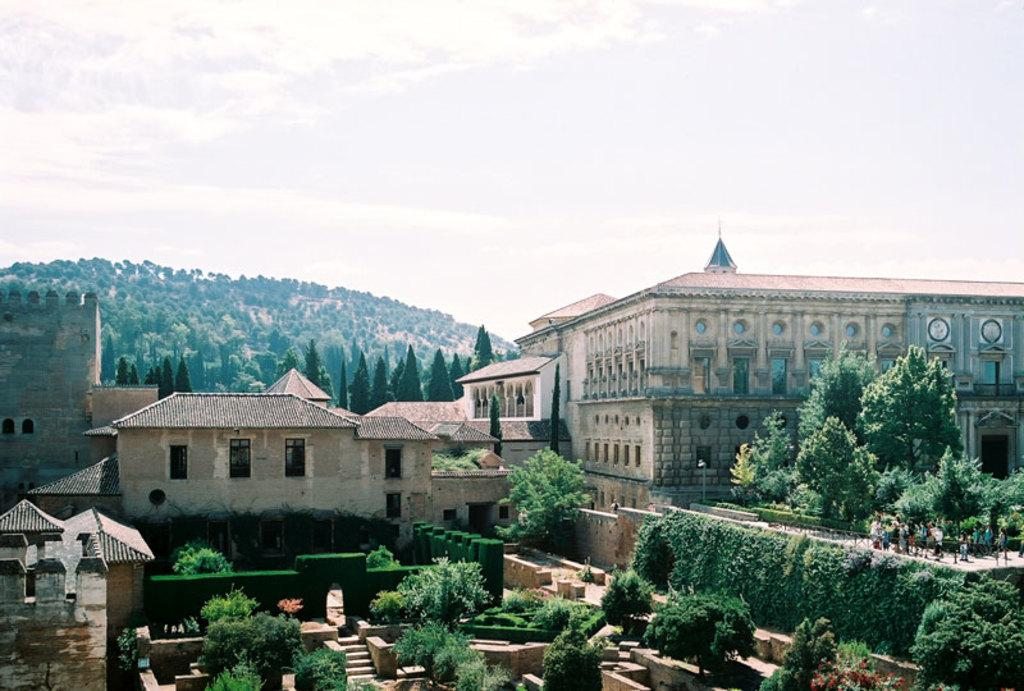What type of structures are located in the front of the image? There are buildings in the front of the image. What can be seen on either side of the buildings? There are trees on either side of the buildings. What is visible in the background of the image? There are hills covered with trees in the background of the image. What is visible at the top of the image? The sky is visible in the image. What can be observed in the sky? Clouds are present in the sky. How much sugar is present in the trees on the left side of the image? There is no sugar present in the trees; they are natural vegetation. What degree of temperature is required for the zinc to melt in the image? There is no zinc present in the image, so this question cannot be answered. 